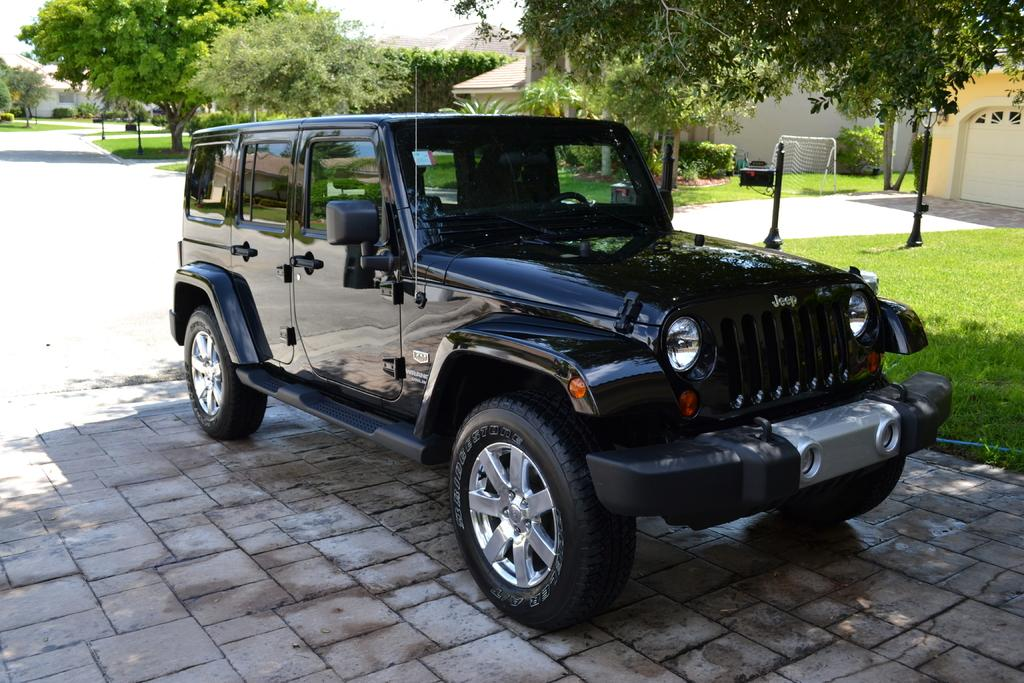What type of vehicle is in the image? There is a vehicle in the image, but the specific type is not mentioned. What feature can be seen on the vehicle? The vehicle has headlights. What type of terrain is visible in the image? There is grass visible in the image. What type of area is shown in the image? The image shows a court. What type of structures are present in the image? There are houses in the image. What type of vegetation is present in the image? Trees are present in the image. What part of the natural environment is visible in the image? The sky is visible in the image. What type of wall can be seen in the image? There is no wall present in the image. How many times is the image copied in the image? The image is not copied within itself, so this question cannot be answered. 